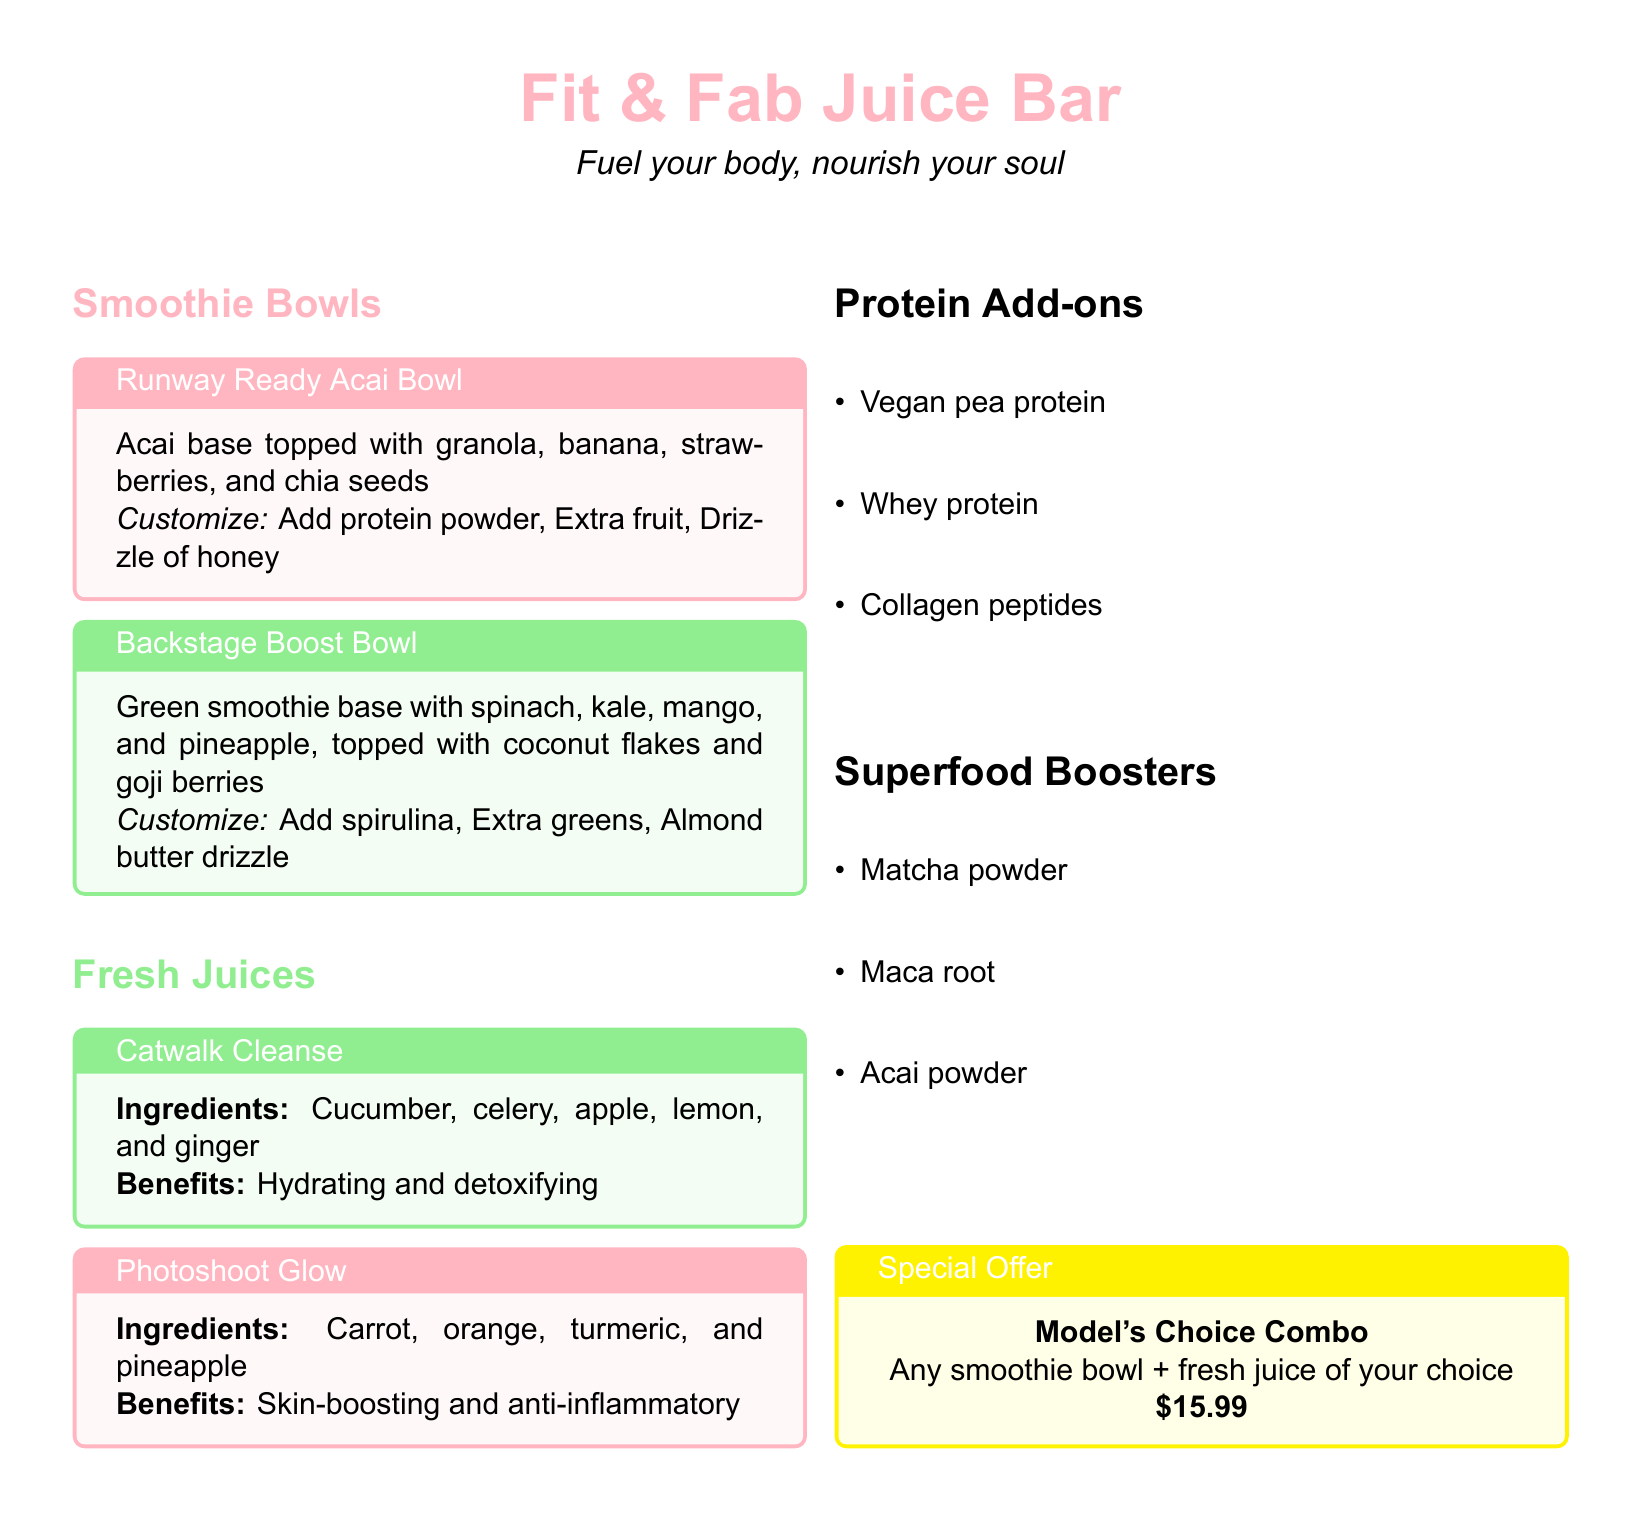What is the name of the smoothie bowl topped with granola, banana, strawberries, and chia seeds? The document states that the smoothie bowl is called "Runway Ready Acai Bowl."
Answer: Runway Ready Acai Bowl What are the main ingredients of the Catwalk Cleanse juice? The main ingredients listed are cucumber, celery, apple, lemon, and ginger.
Answer: Cucumber, celery, apple, lemon, ginger What is included in the Model's Choice Combo? The Model's Choice Combo consists of any smoothie bowl and a fresh juice of your choice.
Answer: Any smoothie bowl + fresh juice What is the price of the Model's Choice Combo? The document specifies that the price for the Model's Choice Combo is $15.99.
Answer: $15.99 How can you customize the Backstage Boost Bowl? The document mentions that you can add spirulina, extra greens, or an almond butter drizzle to customize it.
Answer: Spirulina, Extra greens, Almond butter drizzle Which smoothie bowl base includes spinach and kale? The Backstage Boost Bowl has a green smoothie base that includes spinach and kale.
Answer: Backstage Boost Bowl What is the benefit of the Photoshoot Glow juice? The benefit stated for the Photoshoot Glow is skin-boosting and anti-inflammatory.
Answer: Skin-boosting, anti-inflammatory What type of protein add-ons are mentioned? The document lists vegan pea protein, whey protein, and collagen peptides as protein add-ons.
Answer: Vegan pea protein, Whey protein, Collagen peptides What is the color theme for the smoothie bowls section? The color used for the smoothie bowls section in the document is smoothiepink.
Answer: smoothiepink 